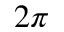<formula> <loc_0><loc_0><loc_500><loc_500>2 \pi</formula> 